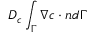<formula> <loc_0><loc_0><loc_500><loc_500>D _ { c } \int _ { \Gamma } \nabla c \cdot n d \Gamma</formula> 